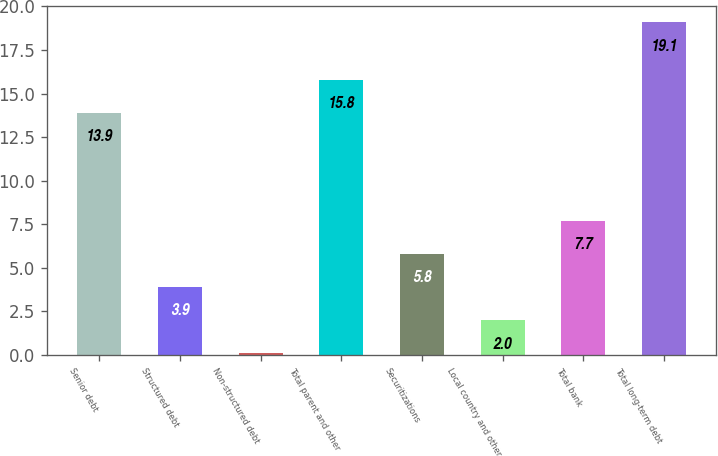<chart> <loc_0><loc_0><loc_500><loc_500><bar_chart><fcel>Senior debt<fcel>Structured debt<fcel>Non-structured debt<fcel>Total parent and other<fcel>Securitizations<fcel>Local country and other<fcel>Total bank<fcel>Total long-term debt<nl><fcel>13.9<fcel>3.9<fcel>0.1<fcel>15.8<fcel>5.8<fcel>2<fcel>7.7<fcel>19.1<nl></chart> 